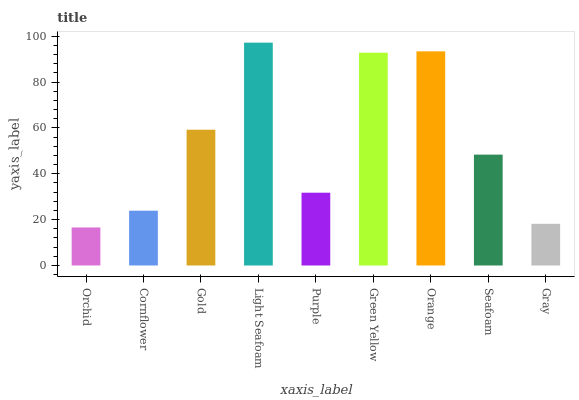Is Orchid the minimum?
Answer yes or no. Yes. Is Light Seafoam the maximum?
Answer yes or no. Yes. Is Cornflower the minimum?
Answer yes or no. No. Is Cornflower the maximum?
Answer yes or no. No. Is Cornflower greater than Orchid?
Answer yes or no. Yes. Is Orchid less than Cornflower?
Answer yes or no. Yes. Is Orchid greater than Cornflower?
Answer yes or no. No. Is Cornflower less than Orchid?
Answer yes or no. No. Is Seafoam the high median?
Answer yes or no. Yes. Is Seafoam the low median?
Answer yes or no. Yes. Is Cornflower the high median?
Answer yes or no. No. Is Gold the low median?
Answer yes or no. No. 